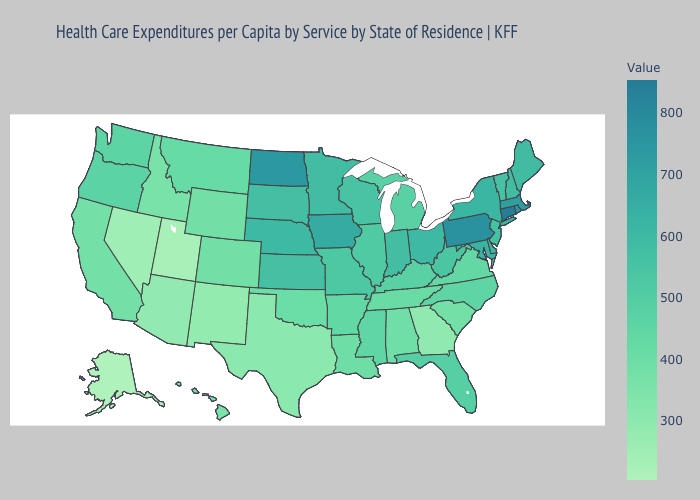Does the map have missing data?
Be succinct. No. Does Connecticut have the highest value in the USA?
Give a very brief answer. Yes. Is the legend a continuous bar?
Answer briefly. Yes. Which states hav the highest value in the South?
Short answer required. Maryland. Does Mississippi have a higher value than Texas?
Write a very short answer. Yes. 